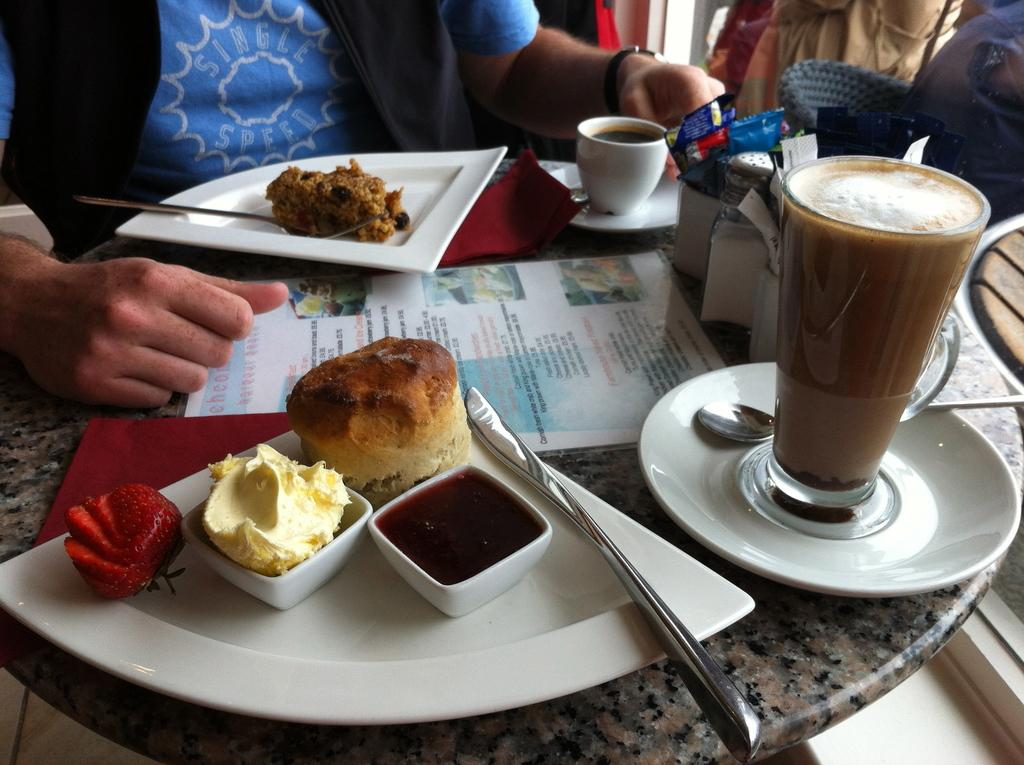How many people are in the image? There are two persons in the image. What are the persons doing in the image? The persons are sitting on chairs. Can you describe the arrangement of the chairs and table in the image? The chairs are around a table. What items can be seen on the table in the image? There is a plate, a glass, a coffee cup, a napkin, ice cream, bread, fruits, sauce, and a food item on the table. What type of summer activity are the persons engaged in, as seen in the image? The image does not depict any summer activity, nor does it provide any context for the season. Can you identify any crooks or frogs in the image? There are no crooks or frogs present in the image. 